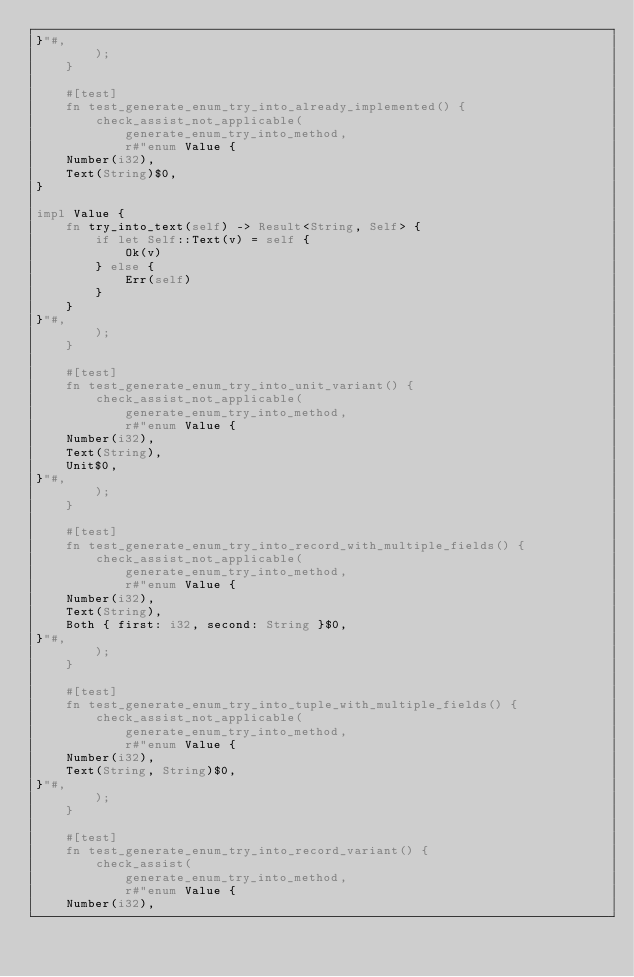Convert code to text. <code><loc_0><loc_0><loc_500><loc_500><_Rust_>}"#,
        );
    }

    #[test]
    fn test_generate_enum_try_into_already_implemented() {
        check_assist_not_applicable(
            generate_enum_try_into_method,
            r#"enum Value {
    Number(i32),
    Text(String)$0,
}

impl Value {
    fn try_into_text(self) -> Result<String, Self> {
        if let Self::Text(v) = self {
            Ok(v)
        } else {
            Err(self)
        }
    }
}"#,
        );
    }

    #[test]
    fn test_generate_enum_try_into_unit_variant() {
        check_assist_not_applicable(
            generate_enum_try_into_method,
            r#"enum Value {
    Number(i32),
    Text(String),
    Unit$0,
}"#,
        );
    }

    #[test]
    fn test_generate_enum_try_into_record_with_multiple_fields() {
        check_assist_not_applicable(
            generate_enum_try_into_method,
            r#"enum Value {
    Number(i32),
    Text(String),
    Both { first: i32, second: String }$0,
}"#,
        );
    }

    #[test]
    fn test_generate_enum_try_into_tuple_with_multiple_fields() {
        check_assist_not_applicable(
            generate_enum_try_into_method,
            r#"enum Value {
    Number(i32),
    Text(String, String)$0,
}"#,
        );
    }

    #[test]
    fn test_generate_enum_try_into_record_variant() {
        check_assist(
            generate_enum_try_into_method,
            r#"enum Value {
    Number(i32),</code> 